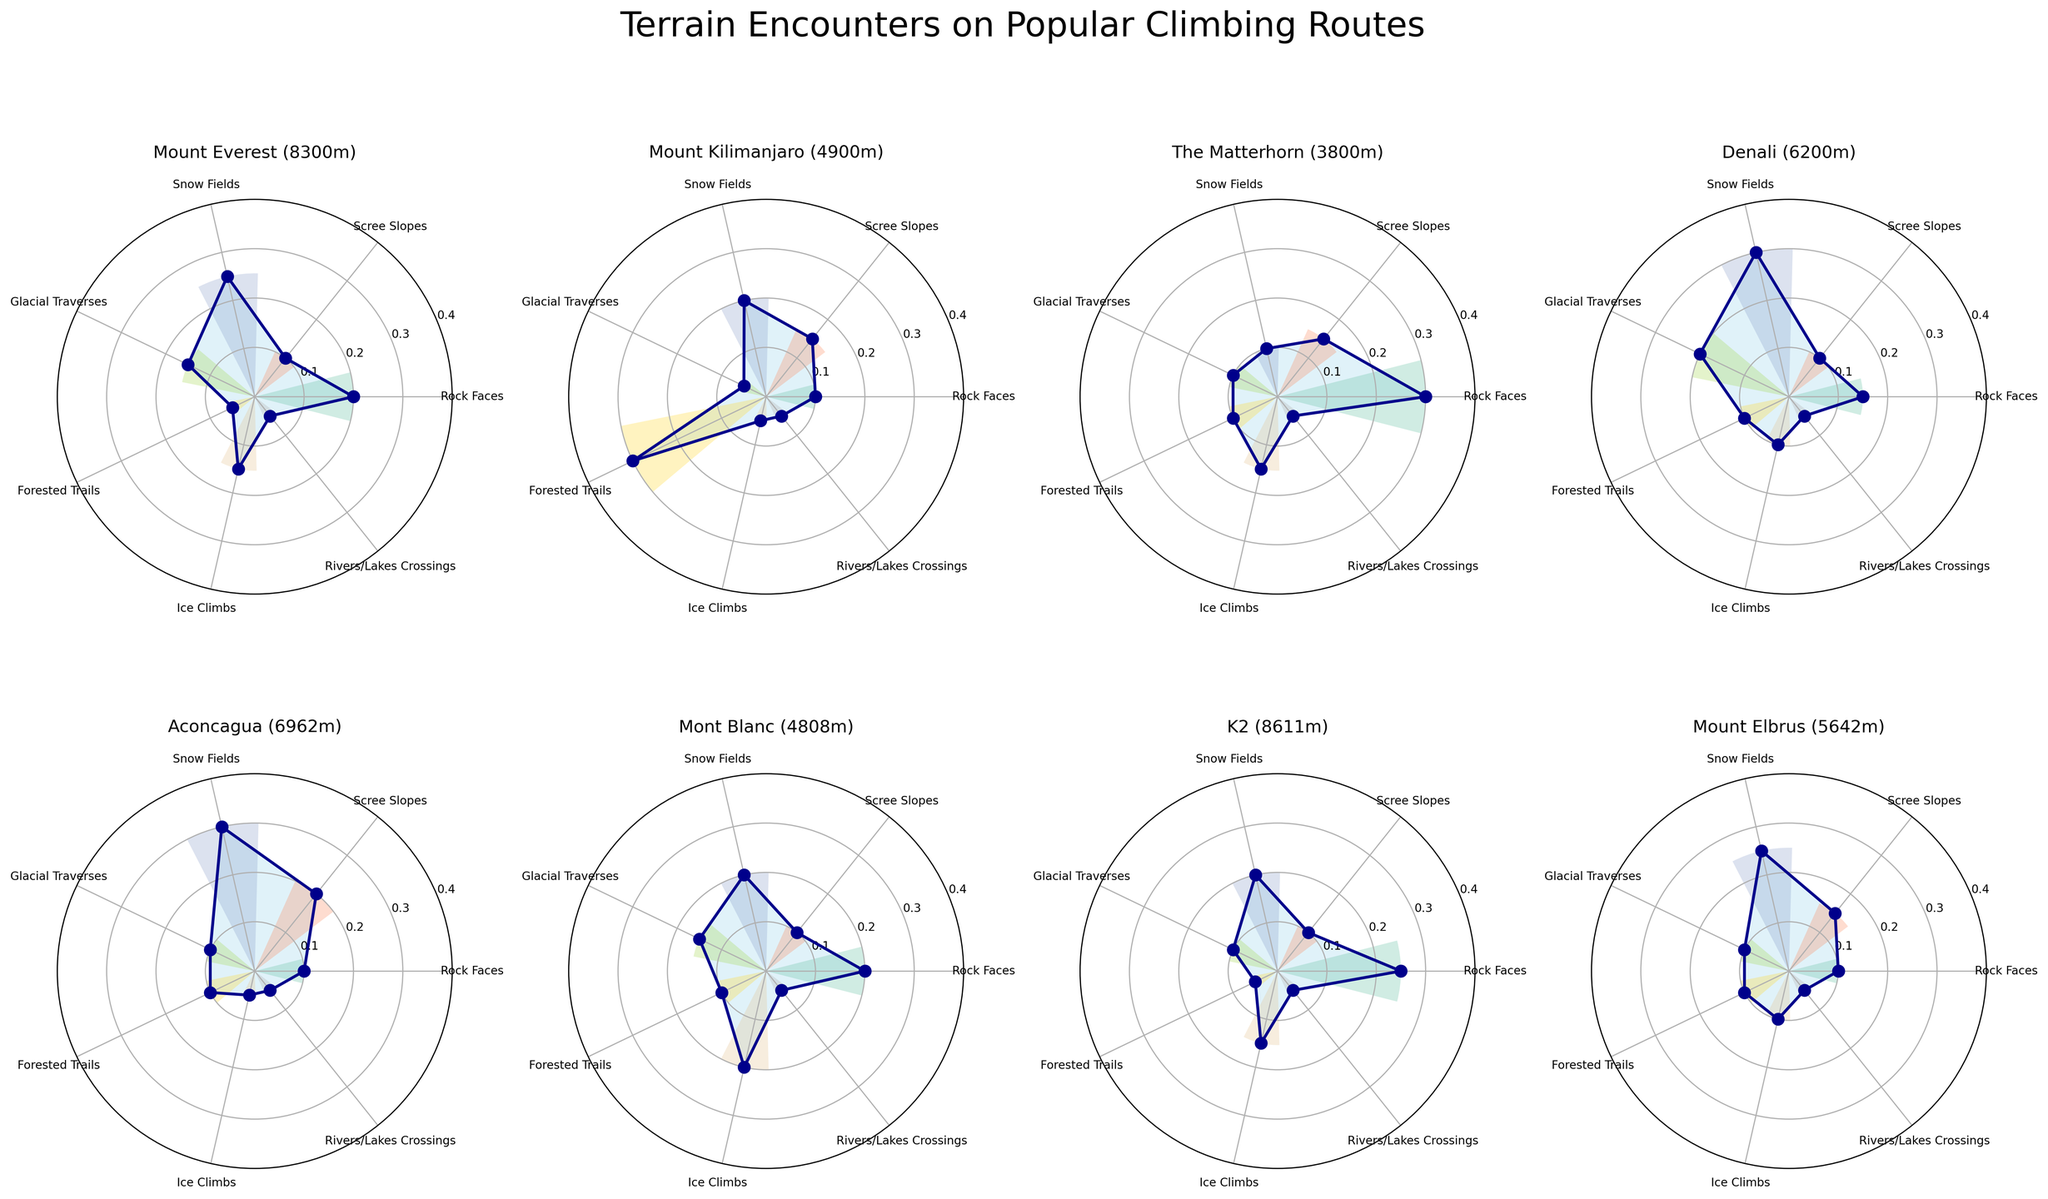Which climbing route encounters the highest frequency of glacial traverses? Determine the glacial traverse frequency for each route by looking at the associated bar heights or areas under the curve, and identify the one with the highest value. Mount Everest and Denali both have the highest frequency at 0.2
Answer: Mount Everest and Denali Which terrain type is encountered with the highest frequency on Mount Kilimanjaro? Look at the heights of the bars or the area under the curve on Mount Kilimanjaro's polar chart to see which terrain type has the most coverage. Forested trails have the highest frequency at 0.3
Answer: Forested trails How does the frequency of ice climbs on the Matterhorn compare to that on Mont Blanc? Compare the height of the ice climbs bar for The Matterhorn and Mont Blanc. Both have an ice climb frequency of 0.15
Answer: They are equal What is the average frequency of rock faces across all routes? Find the frequency of rock faces for each route and calculate the average: (0.2 + 0.1 + 0.3 + 0.15 + 0.1 + 0.2 + 0.25 + 0.1) / 8 = 1.4 / 8 = 0.175
Answer: 0.175 Which route shows the least variety in terrain type encounters? This requires counting the number of different terrain types that have a bar height above 0 for each route and identifying the route with the fewest types. All routes have encounters for each terrain type, but Mount Everest and Kilimanjaro have lower frequencies in most
Answer: Mount Everest and Mount Kilimanjaro What is the combined frequency of snow fields and scree slopes on Aconcagua? Add the frequencies of snow fields and scree slopes for Aconcagua: 0.3 + 0.2 = 0.5
Answer: 0.5 Which climbing route has the highest altitude gain and how is the terrain distribution visually represented in terms of frequencies? Identify the route with the highest altitude gain by looking at the titles and analyzing the distribution of terrain types in its polar chart. K2 has the highest altitude gain, and its terrain frequencies are rock faces (0.25), scree slopes (0.1), snow fields (0.2), glacial traverses (0.1), forested trails (0.05), ice climbs (0.15), river/lake crossings (0.05)
Answer: K2, with specific frequencies as provided How many routes have a snow field frequency of 0.2 or more? Identify the routes where the bar height or area under the curve for snow fields is 0.2 or more. The routes are Mount Everest, Mount Kilimanjaro, Denali, Mont Blanc, K2, and Mount Elbrus
Answer: 6 For which route is the frequency of Rock Faces plus Ice Climbs equal to the frequency of Snow Fields? Sum the frequencies of rock faces and ice climbs, equate them with the frequency of snow fields, and see which route fits. On the Matterhorn, rock faces (0.3) + ice climbs (0.15) equals snow fields (0.1)
Answer: The Matterhorn 